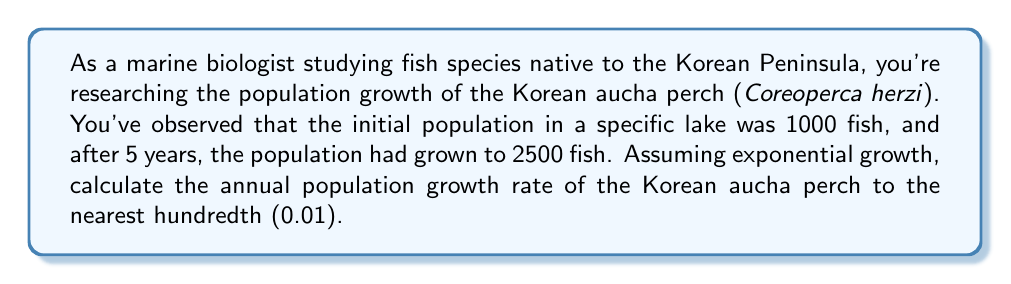Help me with this question. To solve this problem, we'll use the exponential growth formula:

$$P(t) = P_0 \cdot e^{rt}$$

Where:
$P(t)$ is the population at time $t$
$P_0$ is the initial population
$e$ is Euler's number (approximately 2.71828)
$r$ is the growth rate
$t$ is the time period

We know:
$P_0 = 1000$ (initial population)
$P(5) = 2500$ (population after 5 years)
$t = 5$ years

Let's substitute these values into the formula:

$$2500 = 1000 \cdot e^{5r}$$

Divide both sides by 1000:

$$2.5 = e^{5r}$$

Take the natural logarithm of both sides:

$$\ln(2.5) = \ln(e^{5r})$$

$$\ln(2.5) = 5r$$

Solve for $r$:

$$r = \frac{\ln(2.5)}{5}$$

Now, let's calculate:

$$r = \frac{\ln(2.5)}{5} \approx \frac{0.91629073}{5} \approx 0.18325815$$

Rounding to the nearest hundredth:

$$r \approx 0.18$$

This means the annual population growth rate is approximately 0.18 or 18%.
Answer: 0.18 